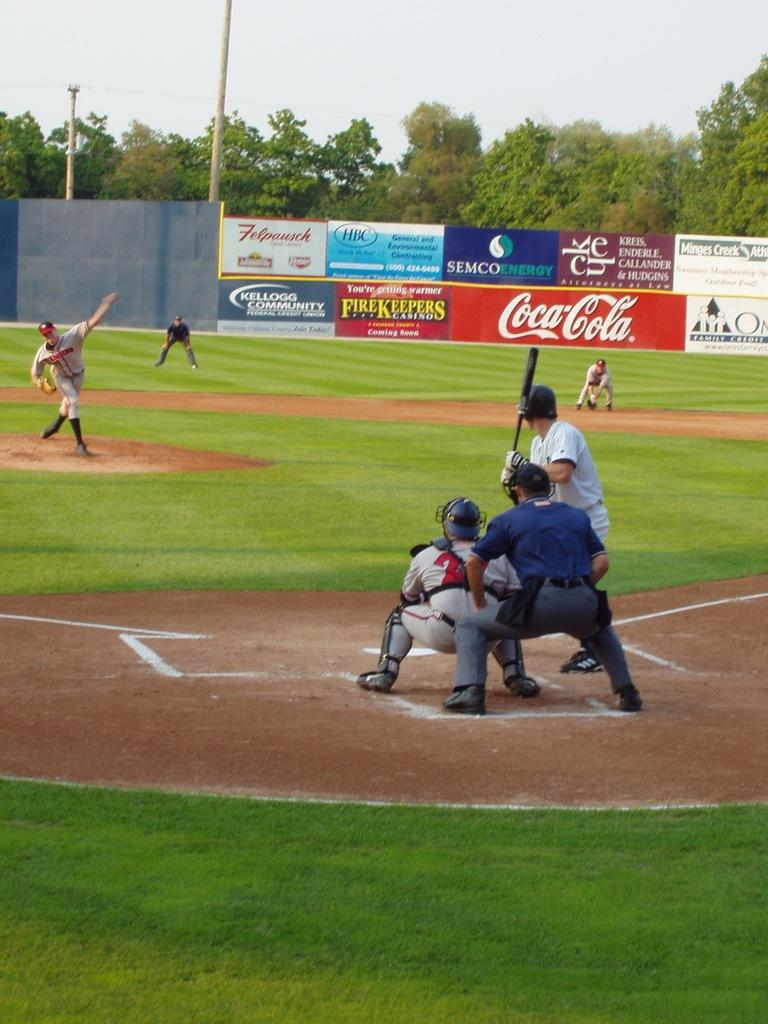Provide a one-sentence caption for the provided image. A baseball game is underway at a stadium with a Coca-Cola sign. 